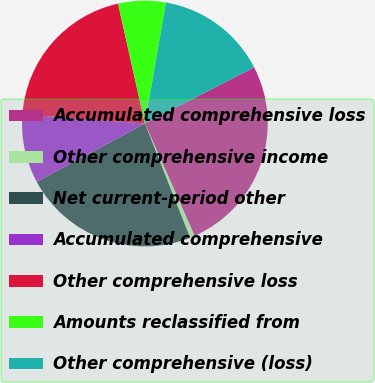<chart> <loc_0><loc_0><loc_500><loc_500><pie_chart><fcel>Accumulated comprehensive loss<fcel>Other comprehensive income<fcel>Net current-period other<fcel>Accumulated comprehensive<fcel>Other comprehensive loss<fcel>Amounts reclassified from<fcel>Other comprehensive (loss)<nl><fcel>25.93%<fcel>0.63%<fcel>23.12%<fcel>9.06%<fcel>20.31%<fcel>6.25%<fcel>14.69%<nl></chart> 